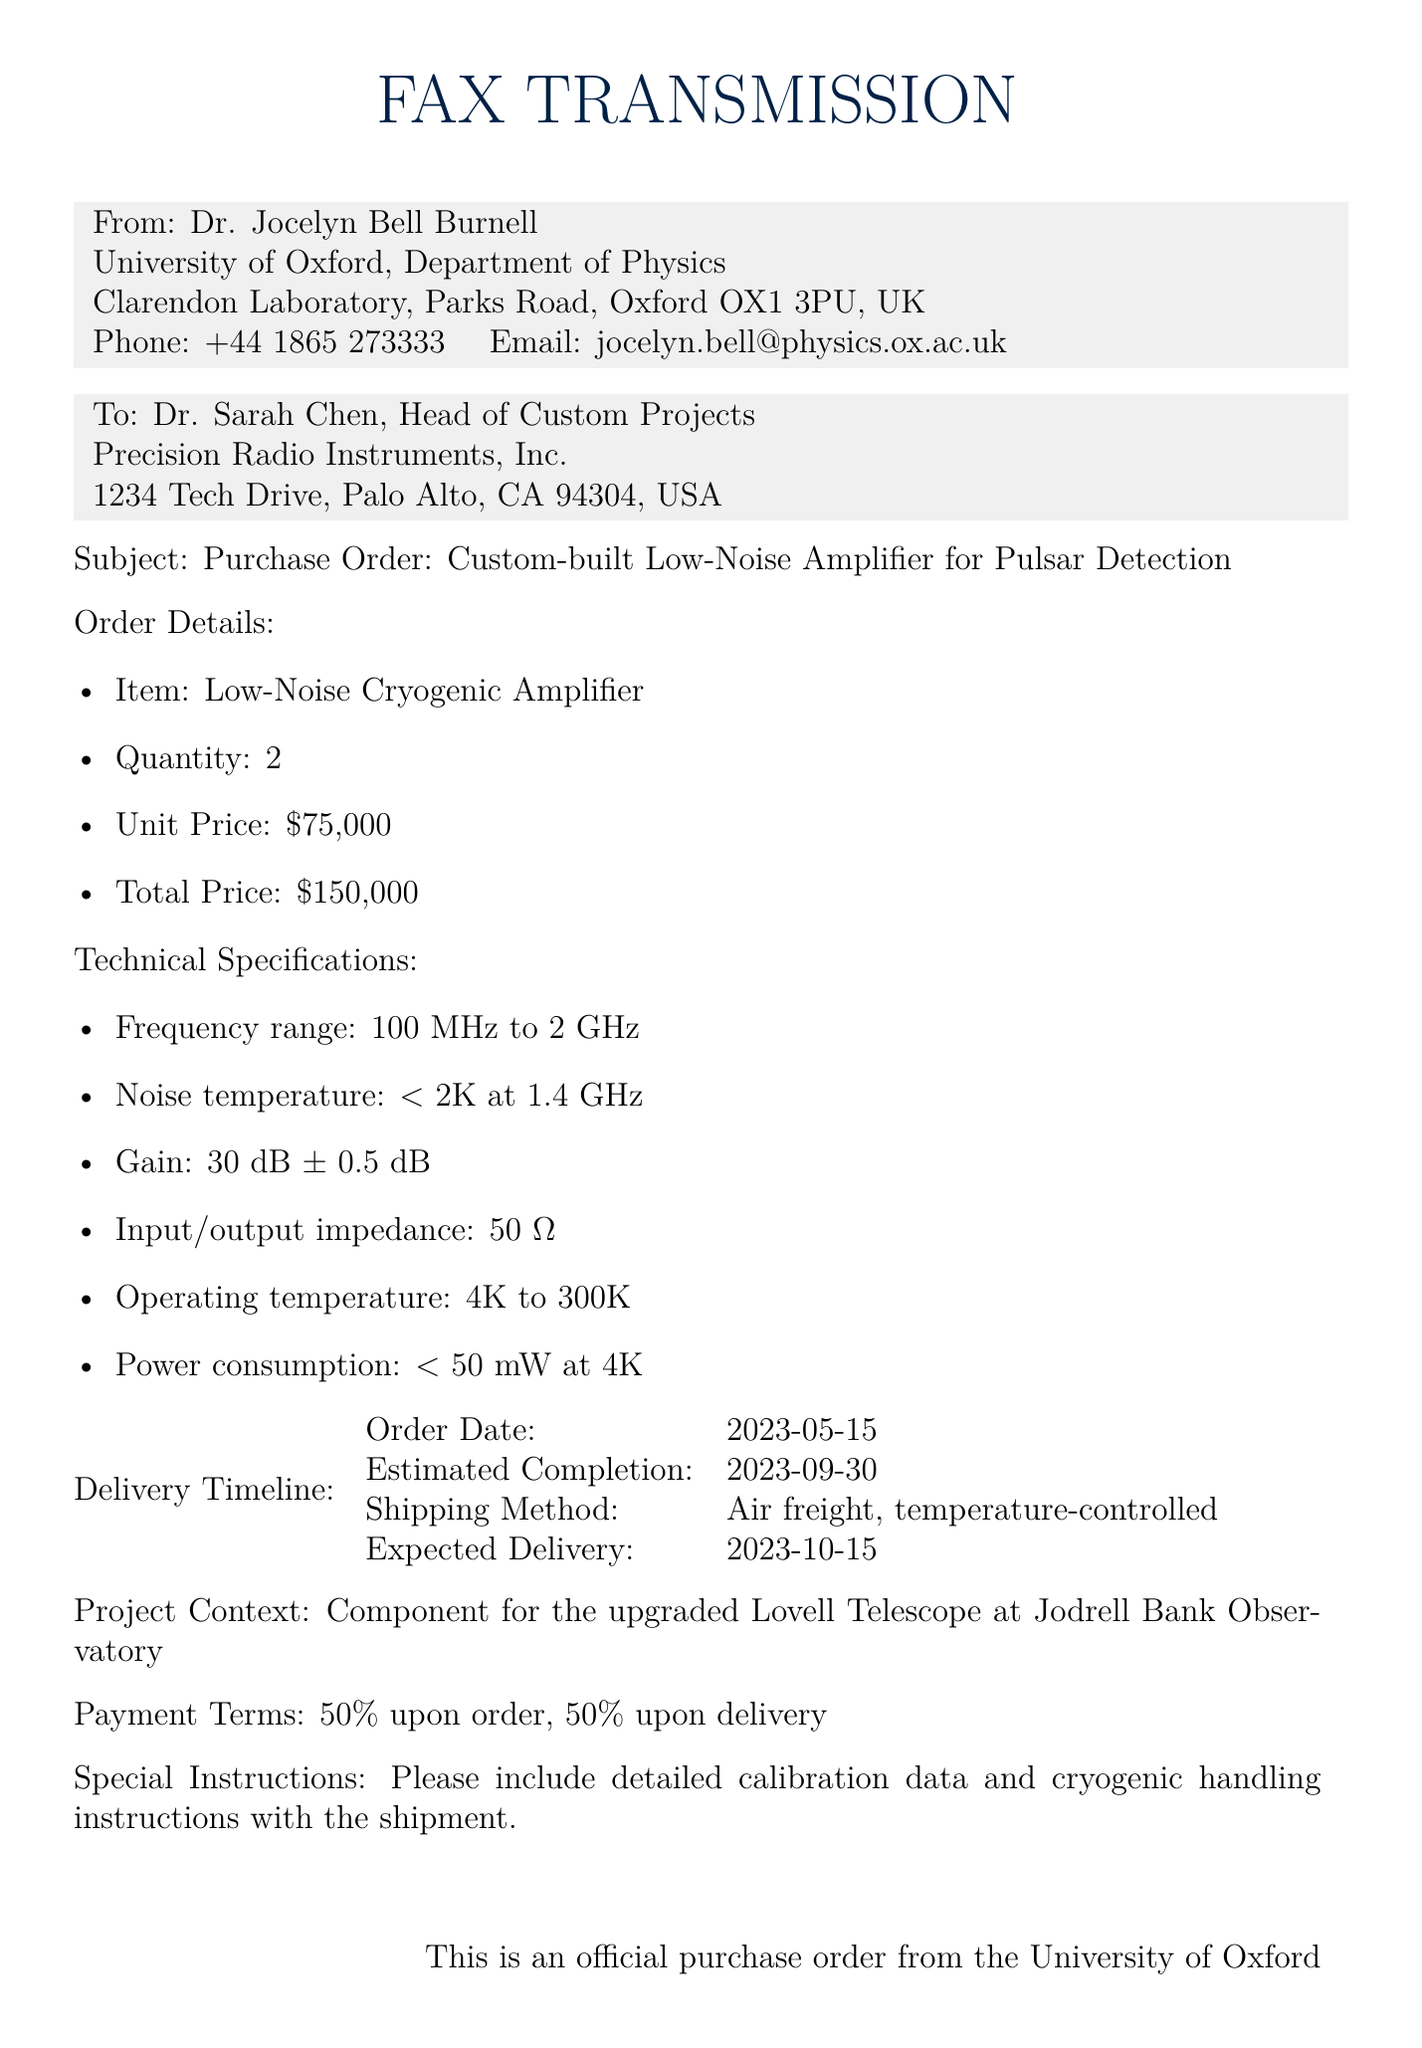what is the item being ordered? The item specified in the purchase order is a Low-Noise Cryogenic Amplifier.
Answer: Low-Noise Cryogenic Amplifier what is the total price of the order? The total price is calculated as the quantity multiplied by the unit price, which is 2 times $75,000.
Answer: $150,000 what is the noise temperature of the amplifier? The noise temperature is mentioned in the technical specifications, and it is specified to be less than 2K at 1.4 GHz.
Answer: < 2K when is the expected delivery date? The expected delivery date is listed in the delivery timeline as 2023-10-15.
Answer: 2023-10-15 what is the operating temperature range for the amplifier? The operating temperature range can be found in the technical specifications, which states from 4K to 300K.
Answer: 4K to 300K who is the recipient of the fax? The fax is addressed to Dr. Sarah Chen, Head of Custom Projects at Precision Radio Instruments, Inc.
Answer: Dr. Sarah Chen what is the payment term structure? The payment terms are specified as 50% upon order and 50% upon delivery.
Answer: 50% upon order, 50% upon delivery what is the estimated completion date for the order? The estimated completion date for the order is stated as 2023-09-30.
Answer: 2023-09-30 